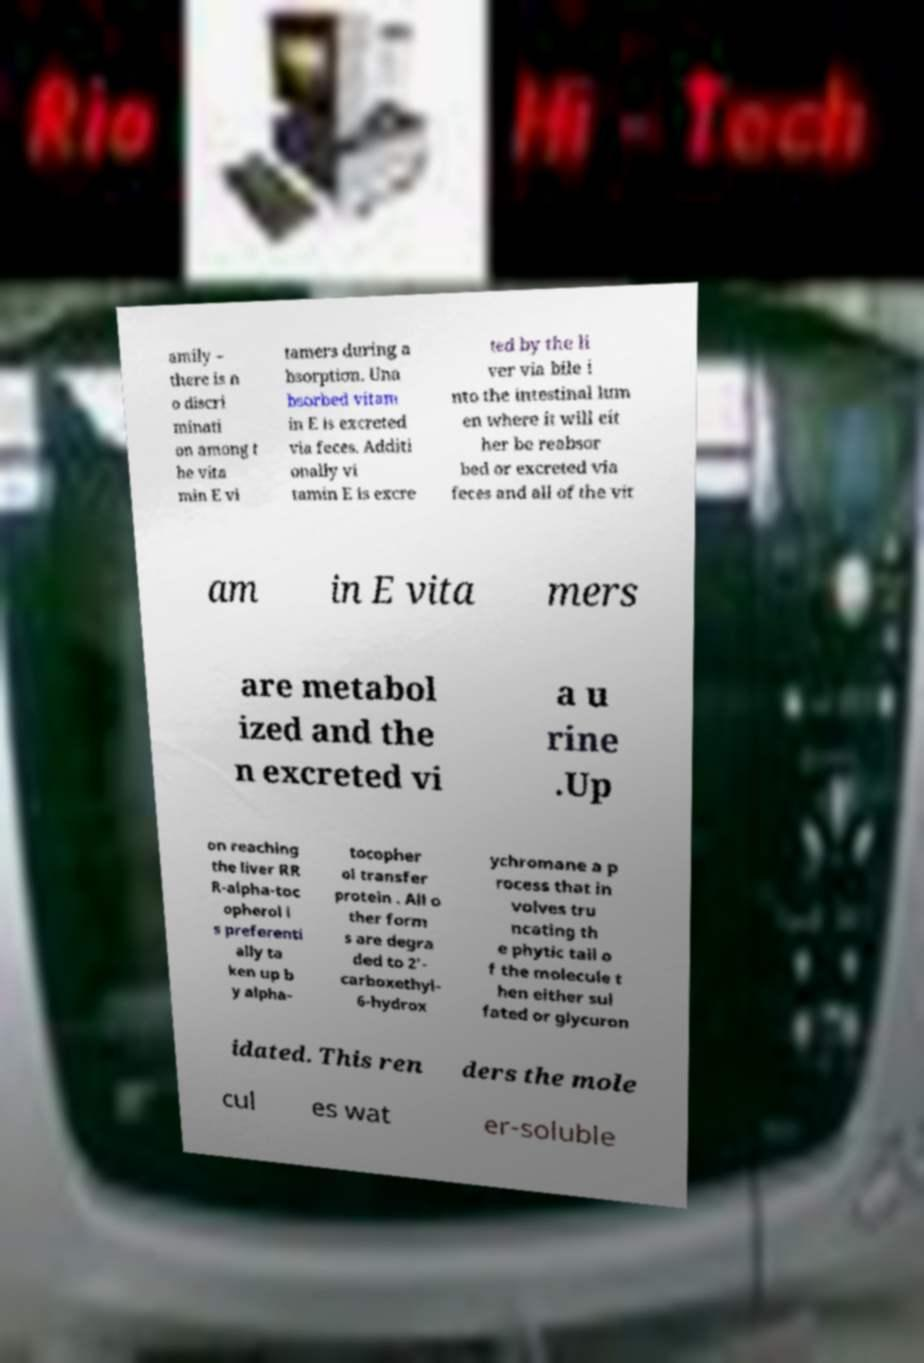Could you assist in decoding the text presented in this image and type it out clearly? amily – there is n o discri minati on among t he vita min E vi tamers during a bsorption. Una bsorbed vitam in E is excreted via feces. Additi onally vi tamin E is excre ted by the li ver via bile i nto the intestinal lum en where it will eit her be reabsor bed or excreted via feces and all of the vit am in E vita mers are metabol ized and the n excreted vi a u rine .Up on reaching the liver RR R-alpha-toc opherol i s preferenti ally ta ken up b y alpha- tocopher ol transfer protein . All o ther form s are degra ded to 2'- carboxethyl- 6-hydrox ychromane a p rocess that in volves tru ncating th e phytic tail o f the molecule t hen either sul fated or glycuron idated. This ren ders the mole cul es wat er-soluble 